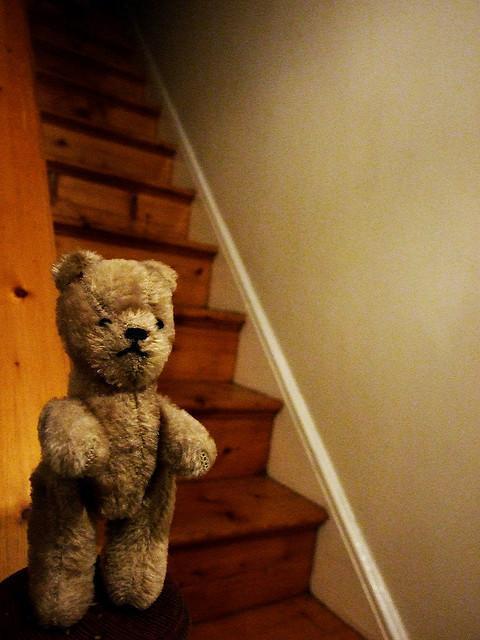How many motorcycles are there in the image?
Give a very brief answer. 0. 